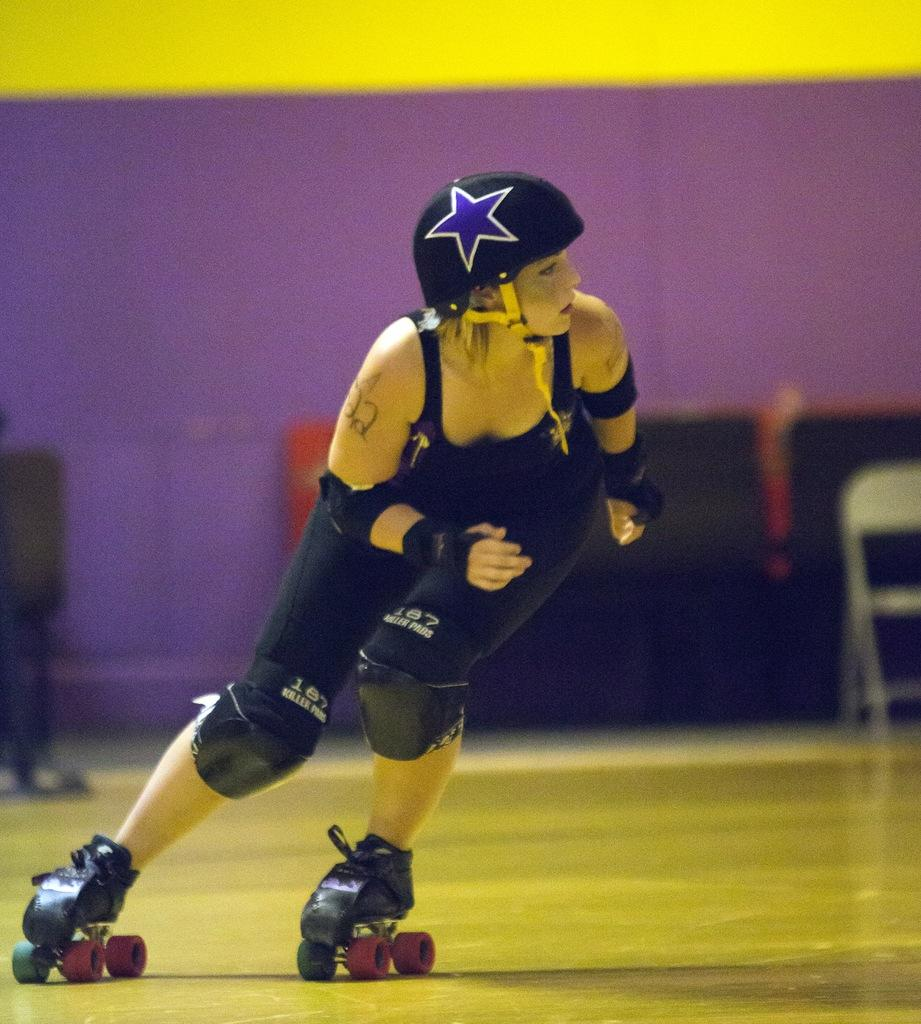What is the person in the image doing? The person is skating. What type of protective gear is the person wearing? The person is wearing a helmet. What type of shoes is the person wearing? The person is wearing skating shoes. What can be seen in the background of the image? There is a chair and a wall in the background of the image. What color is the crayon the person is holding in the image? There is no crayon present in the image; the person is wearing a helmet and skating shoes while skating. What type of dress is the person wearing in the image? The person is not wearing a dress in the image; they are wearing skating shoes and a helmet while skating. 